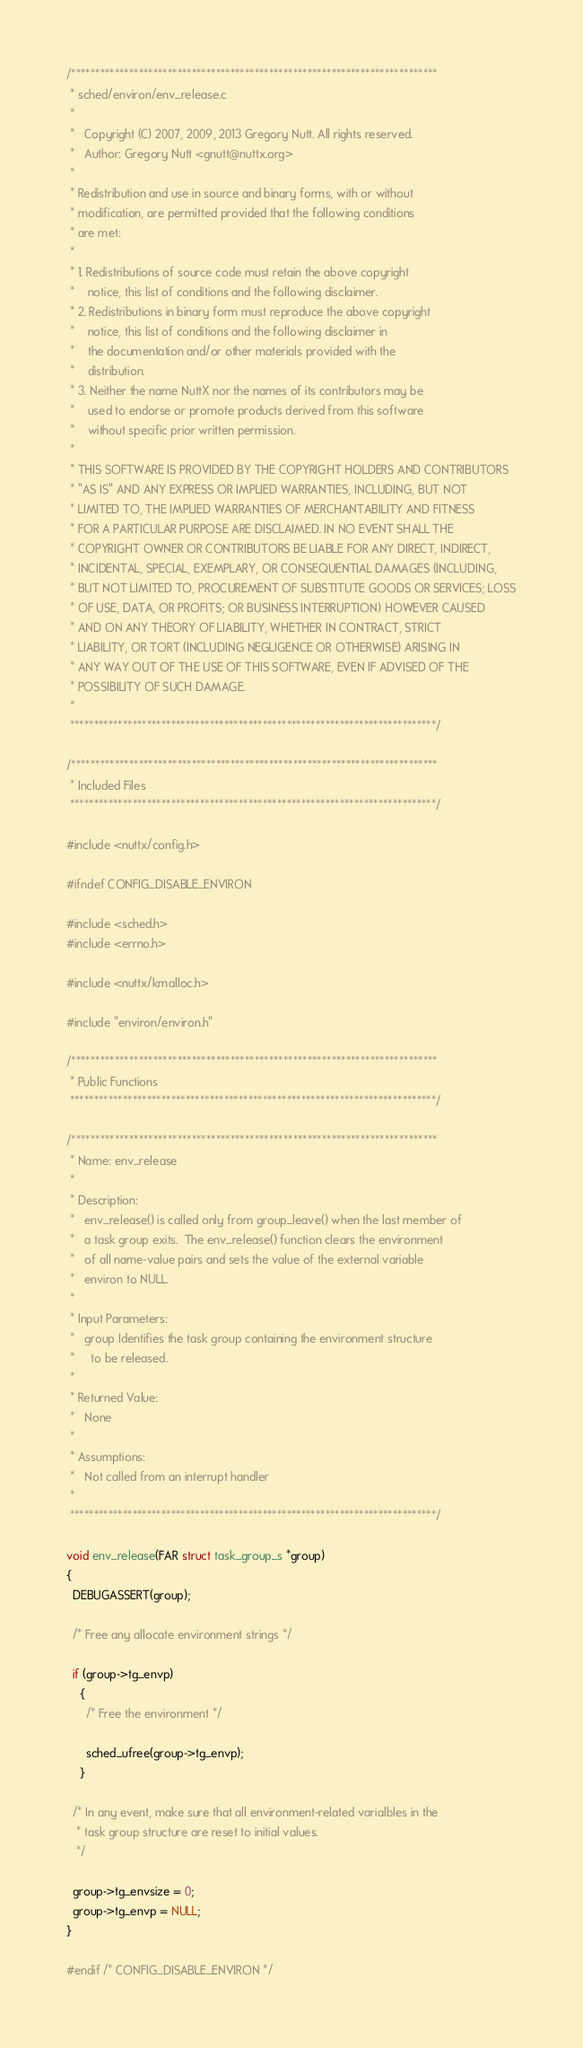Convert code to text. <code><loc_0><loc_0><loc_500><loc_500><_C_>/****************************************************************************
 * sched/environ/env_release.c
 *
 *   Copyright (C) 2007, 2009, 2013 Gregory Nutt. All rights reserved.
 *   Author: Gregory Nutt <gnutt@nuttx.org>
 *
 * Redistribution and use in source and binary forms, with or without
 * modification, are permitted provided that the following conditions
 * are met:
 *
 * 1. Redistributions of source code must retain the above copyright
 *    notice, this list of conditions and the following disclaimer.
 * 2. Redistributions in binary form must reproduce the above copyright
 *    notice, this list of conditions and the following disclaimer in
 *    the documentation and/or other materials provided with the
 *    distribution.
 * 3. Neither the name NuttX nor the names of its contributors may be
 *    used to endorse or promote products derived from this software
 *    without specific prior written permission.
 *
 * THIS SOFTWARE IS PROVIDED BY THE COPYRIGHT HOLDERS AND CONTRIBUTORS
 * "AS IS" AND ANY EXPRESS OR IMPLIED WARRANTIES, INCLUDING, BUT NOT
 * LIMITED TO, THE IMPLIED WARRANTIES OF MERCHANTABILITY AND FITNESS
 * FOR A PARTICULAR PURPOSE ARE DISCLAIMED. IN NO EVENT SHALL THE
 * COPYRIGHT OWNER OR CONTRIBUTORS BE LIABLE FOR ANY DIRECT, INDIRECT,
 * INCIDENTAL, SPECIAL, EXEMPLARY, OR CONSEQUENTIAL DAMAGES (INCLUDING,
 * BUT NOT LIMITED TO, PROCUREMENT OF SUBSTITUTE GOODS OR SERVICES; LOSS
 * OF USE, DATA, OR PROFITS; OR BUSINESS INTERRUPTION) HOWEVER CAUSED
 * AND ON ANY THEORY OF LIABILITY, WHETHER IN CONTRACT, STRICT
 * LIABILITY, OR TORT (INCLUDING NEGLIGENCE OR OTHERWISE) ARISING IN
 * ANY WAY OUT OF THE USE OF THIS SOFTWARE, EVEN IF ADVISED OF THE
 * POSSIBILITY OF SUCH DAMAGE.
 *
 ****************************************************************************/

/****************************************************************************
 * Included Files
 ****************************************************************************/

#include <nuttx/config.h>

#ifndef CONFIG_DISABLE_ENVIRON

#include <sched.h>
#include <errno.h>

#include <nuttx/kmalloc.h>

#include "environ/environ.h"

/****************************************************************************
 * Public Functions
 ****************************************************************************/

/****************************************************************************
 * Name: env_release
 *
 * Description:
 *   env_release() is called only from group_leave() when the last member of
 *   a task group exits.  The env_release() function clears the environment
 *   of all name-value pairs and sets the value of the external variable
 *   environ to NULL.
 *
 * Input Parameters:
 *   group Identifies the task group containing the environment structure
 *     to be released.
 *
 * Returned Value:
 *   None
 *
 * Assumptions:
 *   Not called from an interrupt handler
 *
 ****************************************************************************/

void env_release(FAR struct task_group_s *group)
{
  DEBUGASSERT(group);

  /* Free any allocate environment strings */

  if (group->tg_envp)
    {
      /* Free the environment */

      sched_ufree(group->tg_envp);
    }

  /* In any event, make sure that all environment-related varialbles in the
   * task group structure are reset to initial values.
   */

  group->tg_envsize = 0;
  group->tg_envp = NULL;
}

#endif /* CONFIG_DISABLE_ENVIRON */



</code> 